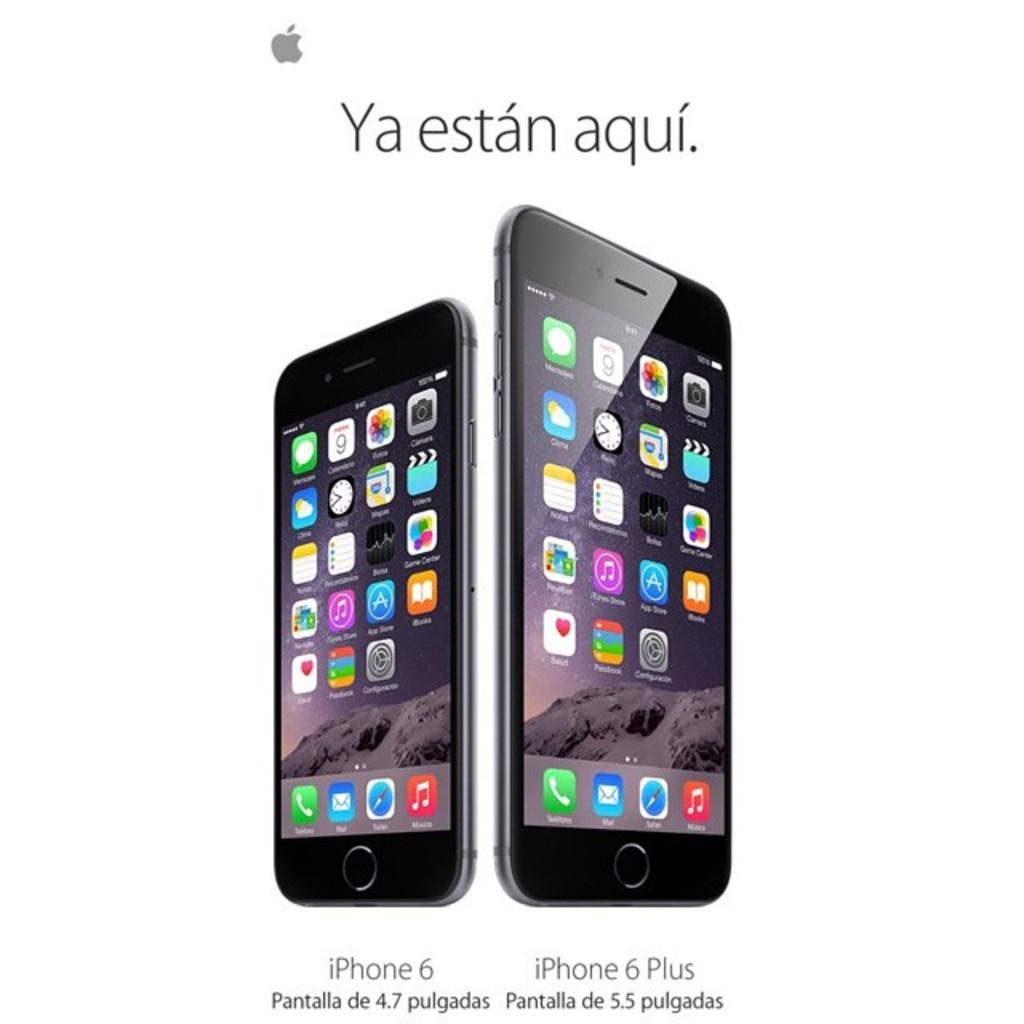What type of phone is on the left?
Make the answer very short. Iphone 6. 